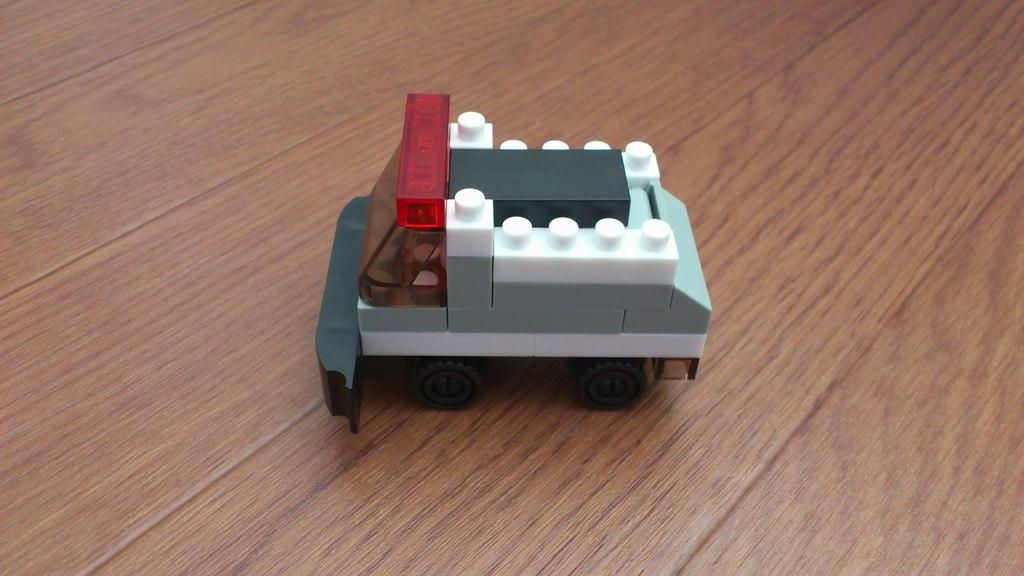What is the main object in the center of the image? There is a table in the center of the image. What is placed on the table? There is a toy vehicle on the table. What can be observed about the toy vehicle's color? The toy vehicle is in a different color. What type of sign is displayed on the toy vehicle in the image? There is no sign displayed on the toy vehicle in the image. What punishment is being given to the toy vehicle in the image? There is no punishment being given to the toy vehicle in the image. 